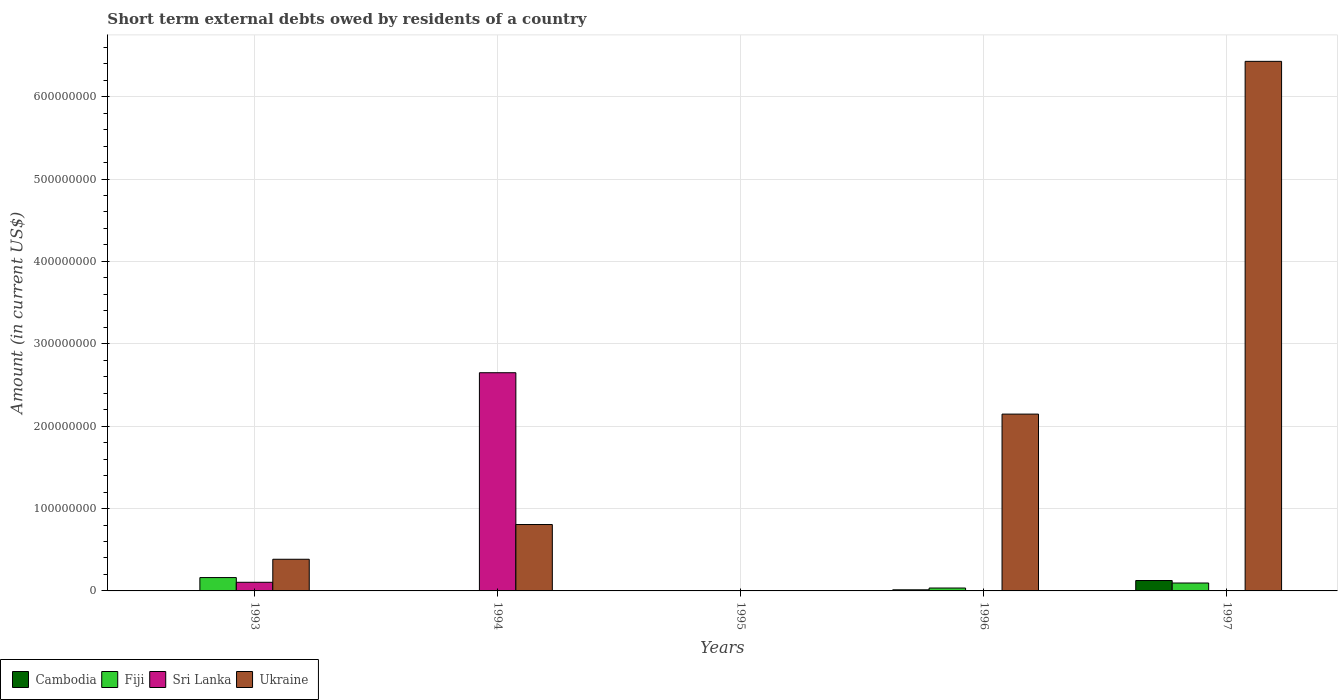How many different coloured bars are there?
Provide a short and direct response. 4. Are the number of bars on each tick of the X-axis equal?
Offer a very short reply. No. How many bars are there on the 5th tick from the right?
Ensure brevity in your answer.  3. In how many cases, is the number of bars for a given year not equal to the number of legend labels?
Provide a succinct answer. 5. What is the amount of short-term external debts owed by residents in Ukraine in 1993?
Provide a succinct answer. 3.84e+07. Across all years, what is the maximum amount of short-term external debts owed by residents in Fiji?
Ensure brevity in your answer.  1.62e+07. What is the total amount of short-term external debts owed by residents in Fiji in the graph?
Provide a succinct answer. 2.93e+07. What is the difference between the amount of short-term external debts owed by residents in Fiji in 1993 and that in 1997?
Give a very brief answer. 6.60e+06. What is the difference between the amount of short-term external debts owed by residents in Ukraine in 1994 and the amount of short-term external debts owed by residents in Fiji in 1995?
Offer a terse response. 8.06e+07. What is the average amount of short-term external debts owed by residents in Fiji per year?
Your answer should be compact. 5.87e+06. In the year 1997, what is the difference between the amount of short-term external debts owed by residents in Ukraine and amount of short-term external debts owed by residents in Fiji?
Your response must be concise. 6.33e+08. What is the ratio of the amount of short-term external debts owed by residents in Fiji in 1993 to that in 1996?
Ensure brevity in your answer.  4.62. Is the amount of short-term external debts owed by residents in Ukraine in 1996 less than that in 1997?
Give a very brief answer. Yes. Is the difference between the amount of short-term external debts owed by residents in Ukraine in 1993 and 1996 greater than the difference between the amount of short-term external debts owed by residents in Fiji in 1993 and 1996?
Keep it short and to the point. No. What is the difference between the highest and the second highest amount of short-term external debts owed by residents in Ukraine?
Your response must be concise. 4.28e+08. What is the difference between the highest and the lowest amount of short-term external debts owed by residents in Cambodia?
Give a very brief answer. 1.26e+07. In how many years, is the amount of short-term external debts owed by residents in Ukraine greater than the average amount of short-term external debts owed by residents in Ukraine taken over all years?
Your answer should be very brief. 2. Is the sum of the amount of short-term external debts owed by residents in Ukraine in 1993 and 1997 greater than the maximum amount of short-term external debts owed by residents in Cambodia across all years?
Your response must be concise. Yes. Is it the case that in every year, the sum of the amount of short-term external debts owed by residents in Ukraine and amount of short-term external debts owed by residents in Cambodia is greater than the sum of amount of short-term external debts owed by residents in Sri Lanka and amount of short-term external debts owed by residents in Fiji?
Your response must be concise. No. How many bars are there?
Your answer should be very brief. 11. How many years are there in the graph?
Your response must be concise. 5. What is the difference between two consecutive major ticks on the Y-axis?
Provide a short and direct response. 1.00e+08. Does the graph contain grids?
Your answer should be compact. Yes. Where does the legend appear in the graph?
Your answer should be very brief. Bottom left. How are the legend labels stacked?
Offer a very short reply. Horizontal. What is the title of the graph?
Give a very brief answer. Short term external debts owed by residents of a country. Does "Venezuela" appear as one of the legend labels in the graph?
Give a very brief answer. No. What is the label or title of the X-axis?
Your answer should be compact. Years. What is the label or title of the Y-axis?
Your answer should be compact. Amount (in current US$). What is the Amount (in current US$) of Cambodia in 1993?
Make the answer very short. 0. What is the Amount (in current US$) of Fiji in 1993?
Provide a succinct answer. 1.62e+07. What is the Amount (in current US$) of Sri Lanka in 1993?
Make the answer very short. 1.05e+07. What is the Amount (in current US$) in Ukraine in 1993?
Your response must be concise. 3.84e+07. What is the Amount (in current US$) in Cambodia in 1994?
Offer a terse response. 0. What is the Amount (in current US$) of Fiji in 1994?
Make the answer very short. 0. What is the Amount (in current US$) of Sri Lanka in 1994?
Provide a short and direct response. 2.65e+08. What is the Amount (in current US$) of Ukraine in 1994?
Ensure brevity in your answer.  8.06e+07. What is the Amount (in current US$) in Fiji in 1995?
Your answer should be compact. 0. What is the Amount (in current US$) of Cambodia in 1996?
Provide a succinct answer. 1.34e+06. What is the Amount (in current US$) of Fiji in 1996?
Offer a terse response. 3.51e+06. What is the Amount (in current US$) in Ukraine in 1996?
Keep it short and to the point. 2.15e+08. What is the Amount (in current US$) in Cambodia in 1997?
Make the answer very short. 1.26e+07. What is the Amount (in current US$) in Fiji in 1997?
Your response must be concise. 9.61e+06. What is the Amount (in current US$) in Sri Lanka in 1997?
Your response must be concise. 0. What is the Amount (in current US$) of Ukraine in 1997?
Give a very brief answer. 6.43e+08. Across all years, what is the maximum Amount (in current US$) in Cambodia?
Keep it short and to the point. 1.26e+07. Across all years, what is the maximum Amount (in current US$) in Fiji?
Make the answer very short. 1.62e+07. Across all years, what is the maximum Amount (in current US$) in Sri Lanka?
Your answer should be very brief. 2.65e+08. Across all years, what is the maximum Amount (in current US$) in Ukraine?
Ensure brevity in your answer.  6.43e+08. Across all years, what is the minimum Amount (in current US$) in Cambodia?
Ensure brevity in your answer.  0. Across all years, what is the minimum Amount (in current US$) of Fiji?
Your response must be concise. 0. Across all years, what is the minimum Amount (in current US$) of Sri Lanka?
Provide a short and direct response. 0. Across all years, what is the minimum Amount (in current US$) in Ukraine?
Make the answer very short. 0. What is the total Amount (in current US$) in Cambodia in the graph?
Your answer should be compact. 1.40e+07. What is the total Amount (in current US$) in Fiji in the graph?
Give a very brief answer. 2.93e+07. What is the total Amount (in current US$) in Sri Lanka in the graph?
Provide a succinct answer. 2.75e+08. What is the total Amount (in current US$) in Ukraine in the graph?
Provide a succinct answer. 9.77e+08. What is the difference between the Amount (in current US$) of Sri Lanka in 1993 and that in 1994?
Your answer should be very brief. -2.54e+08. What is the difference between the Amount (in current US$) in Ukraine in 1993 and that in 1994?
Offer a terse response. -4.22e+07. What is the difference between the Amount (in current US$) in Fiji in 1993 and that in 1996?
Make the answer very short. 1.27e+07. What is the difference between the Amount (in current US$) in Ukraine in 1993 and that in 1996?
Make the answer very short. -1.76e+08. What is the difference between the Amount (in current US$) of Fiji in 1993 and that in 1997?
Make the answer very short. 6.60e+06. What is the difference between the Amount (in current US$) of Ukraine in 1993 and that in 1997?
Give a very brief answer. -6.04e+08. What is the difference between the Amount (in current US$) of Ukraine in 1994 and that in 1996?
Your answer should be very brief. -1.34e+08. What is the difference between the Amount (in current US$) of Ukraine in 1994 and that in 1997?
Offer a terse response. -5.62e+08. What is the difference between the Amount (in current US$) of Cambodia in 1996 and that in 1997?
Your answer should be very brief. -1.13e+07. What is the difference between the Amount (in current US$) in Fiji in 1996 and that in 1997?
Your answer should be compact. -6.10e+06. What is the difference between the Amount (in current US$) in Ukraine in 1996 and that in 1997?
Offer a very short reply. -4.28e+08. What is the difference between the Amount (in current US$) of Fiji in 1993 and the Amount (in current US$) of Sri Lanka in 1994?
Make the answer very short. -2.49e+08. What is the difference between the Amount (in current US$) in Fiji in 1993 and the Amount (in current US$) in Ukraine in 1994?
Your response must be concise. -6.44e+07. What is the difference between the Amount (in current US$) of Sri Lanka in 1993 and the Amount (in current US$) of Ukraine in 1994?
Provide a succinct answer. -7.01e+07. What is the difference between the Amount (in current US$) in Fiji in 1993 and the Amount (in current US$) in Ukraine in 1996?
Your response must be concise. -1.98e+08. What is the difference between the Amount (in current US$) of Sri Lanka in 1993 and the Amount (in current US$) of Ukraine in 1996?
Provide a short and direct response. -2.04e+08. What is the difference between the Amount (in current US$) in Fiji in 1993 and the Amount (in current US$) in Ukraine in 1997?
Your answer should be compact. -6.27e+08. What is the difference between the Amount (in current US$) of Sri Lanka in 1993 and the Amount (in current US$) of Ukraine in 1997?
Give a very brief answer. -6.32e+08. What is the difference between the Amount (in current US$) in Sri Lanka in 1994 and the Amount (in current US$) in Ukraine in 1996?
Make the answer very short. 5.02e+07. What is the difference between the Amount (in current US$) in Sri Lanka in 1994 and the Amount (in current US$) in Ukraine in 1997?
Your answer should be compact. -3.78e+08. What is the difference between the Amount (in current US$) of Cambodia in 1996 and the Amount (in current US$) of Fiji in 1997?
Offer a terse response. -8.27e+06. What is the difference between the Amount (in current US$) of Cambodia in 1996 and the Amount (in current US$) of Ukraine in 1997?
Provide a succinct answer. -6.42e+08. What is the difference between the Amount (in current US$) of Fiji in 1996 and the Amount (in current US$) of Ukraine in 1997?
Provide a short and direct response. -6.39e+08. What is the average Amount (in current US$) in Cambodia per year?
Offer a very short reply. 2.79e+06. What is the average Amount (in current US$) in Fiji per year?
Give a very brief answer. 5.87e+06. What is the average Amount (in current US$) of Sri Lanka per year?
Give a very brief answer. 5.51e+07. What is the average Amount (in current US$) in Ukraine per year?
Offer a very short reply. 1.95e+08. In the year 1993, what is the difference between the Amount (in current US$) in Fiji and Amount (in current US$) in Sri Lanka?
Your answer should be very brief. 5.73e+06. In the year 1993, what is the difference between the Amount (in current US$) in Fiji and Amount (in current US$) in Ukraine?
Provide a short and direct response. -2.22e+07. In the year 1993, what is the difference between the Amount (in current US$) of Sri Lanka and Amount (in current US$) of Ukraine?
Keep it short and to the point. -2.80e+07. In the year 1994, what is the difference between the Amount (in current US$) of Sri Lanka and Amount (in current US$) of Ukraine?
Provide a succinct answer. 1.84e+08. In the year 1996, what is the difference between the Amount (in current US$) of Cambodia and Amount (in current US$) of Fiji?
Keep it short and to the point. -2.17e+06. In the year 1996, what is the difference between the Amount (in current US$) of Cambodia and Amount (in current US$) of Ukraine?
Your answer should be very brief. -2.13e+08. In the year 1996, what is the difference between the Amount (in current US$) of Fiji and Amount (in current US$) of Ukraine?
Make the answer very short. -2.11e+08. In the year 1997, what is the difference between the Amount (in current US$) in Cambodia and Amount (in current US$) in Fiji?
Your answer should be compact. 3.01e+06. In the year 1997, what is the difference between the Amount (in current US$) in Cambodia and Amount (in current US$) in Ukraine?
Offer a very short reply. -6.30e+08. In the year 1997, what is the difference between the Amount (in current US$) in Fiji and Amount (in current US$) in Ukraine?
Give a very brief answer. -6.33e+08. What is the ratio of the Amount (in current US$) in Sri Lanka in 1993 to that in 1994?
Offer a very short reply. 0.04. What is the ratio of the Amount (in current US$) of Ukraine in 1993 to that in 1994?
Give a very brief answer. 0.48. What is the ratio of the Amount (in current US$) in Fiji in 1993 to that in 1996?
Give a very brief answer. 4.62. What is the ratio of the Amount (in current US$) in Ukraine in 1993 to that in 1996?
Ensure brevity in your answer.  0.18. What is the ratio of the Amount (in current US$) in Fiji in 1993 to that in 1997?
Make the answer very short. 1.69. What is the ratio of the Amount (in current US$) of Ukraine in 1993 to that in 1997?
Offer a very short reply. 0.06. What is the ratio of the Amount (in current US$) in Ukraine in 1994 to that in 1996?
Your response must be concise. 0.38. What is the ratio of the Amount (in current US$) of Ukraine in 1994 to that in 1997?
Offer a very short reply. 0.13. What is the ratio of the Amount (in current US$) of Cambodia in 1996 to that in 1997?
Keep it short and to the point. 0.11. What is the ratio of the Amount (in current US$) of Fiji in 1996 to that in 1997?
Ensure brevity in your answer.  0.37. What is the ratio of the Amount (in current US$) in Ukraine in 1996 to that in 1997?
Your response must be concise. 0.33. What is the difference between the highest and the second highest Amount (in current US$) in Fiji?
Offer a very short reply. 6.60e+06. What is the difference between the highest and the second highest Amount (in current US$) in Ukraine?
Ensure brevity in your answer.  4.28e+08. What is the difference between the highest and the lowest Amount (in current US$) of Cambodia?
Your answer should be very brief. 1.26e+07. What is the difference between the highest and the lowest Amount (in current US$) in Fiji?
Give a very brief answer. 1.62e+07. What is the difference between the highest and the lowest Amount (in current US$) in Sri Lanka?
Your answer should be compact. 2.65e+08. What is the difference between the highest and the lowest Amount (in current US$) of Ukraine?
Offer a terse response. 6.43e+08. 